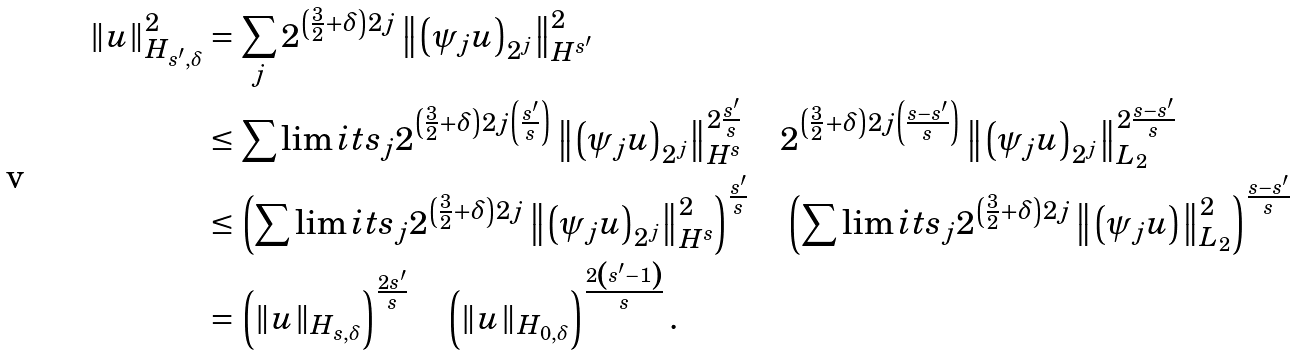Convert formula to latex. <formula><loc_0><loc_0><loc_500><loc_500>\| u \| _ { H _ { s ^ { \prime } , \delta } } ^ { 2 } & = \sum _ { j } 2 ^ { \left ( \frac { 3 } { 2 } + \delta \right ) 2 j } \left \| \left ( \psi _ { j } u \right ) _ { 2 ^ { j } } \right \| _ { H ^ { s ^ { \prime } } } ^ { 2 } \\ & \leq \sum \lim i t s _ { j } 2 ^ { \left ( \frac { 3 } { 2 } + \delta \right ) 2 j \left ( \frac { s ^ { \prime } } { s } \right ) } \left \| \left ( \psi _ { j } u \right ) _ { 2 ^ { j } } \right \| _ { H ^ { s } } ^ { 2 \frac { s ^ { \prime } } { s } } \quad 2 ^ { \left ( \frac { 3 } { 2 } + \delta \right ) 2 j \left ( \frac { s - s ^ { \prime } } { s } \right ) } \left \| \left ( \psi _ { j } u \right ) _ { 2 ^ { j } } \right \| _ { L _ { 2 } } ^ { 2 \frac { s - s ^ { \prime } } { s } } \\ & \leq \left ( \sum \lim i t s _ { j } 2 ^ { \left ( \frac { 3 } { 2 } + \delta \right ) 2 j } \left \| \left ( \psi _ { j } u \right ) _ { 2 ^ { j } } \right \| _ { H ^ { s } } ^ { 2 } \right ) ^ { \frac { s ^ { \prime } } { s } } \quad \left ( \sum \lim i t s _ { j } 2 ^ { \left ( \frac { 3 } { 2 } + \delta \right ) 2 j } \left \| \left ( \psi _ { j } u \right ) \right \| ^ { 2 } _ { L _ { 2 } } \right ) ^ { \frac { s - s ^ { \prime } } { s } } \\ & = \left ( \| u \| _ { H _ { s , \delta } } \right ) ^ { \frac { 2 s ^ { \prime } } { s } } \quad \left ( \| u \| _ { H _ { 0 , \delta } } \right ) ^ { \frac { 2 \left ( s ^ { \prime } - 1 \right ) } { s } } .</formula> 